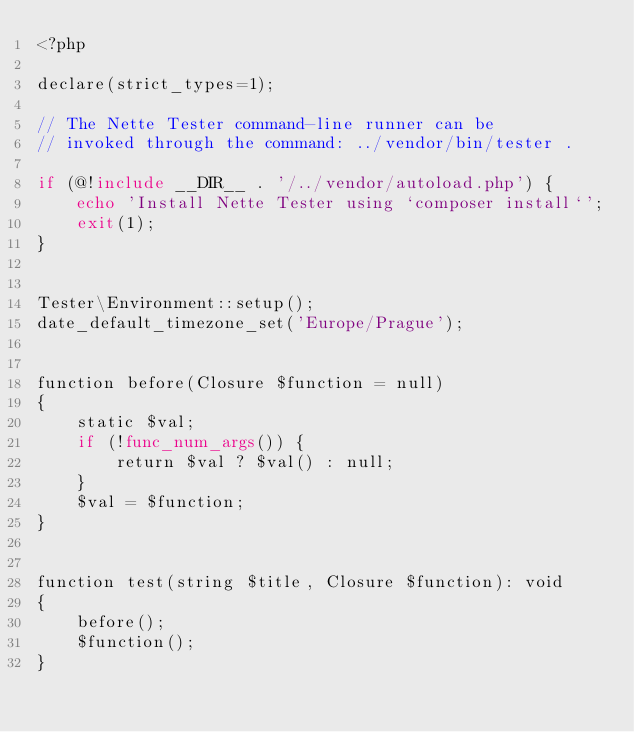<code> <loc_0><loc_0><loc_500><loc_500><_PHP_><?php

declare(strict_types=1);

// The Nette Tester command-line runner can be
// invoked through the command: ../vendor/bin/tester .

if (@!include __DIR__ . '/../vendor/autoload.php') {
	echo 'Install Nette Tester using `composer install`';
	exit(1);
}


Tester\Environment::setup();
date_default_timezone_set('Europe/Prague');


function before(Closure $function = null)
{
	static $val;
	if (!func_num_args()) {
		return $val ? $val() : null;
	}
	$val = $function;
}


function test(string $title, Closure $function): void
{
	before();
	$function();
}
</code> 